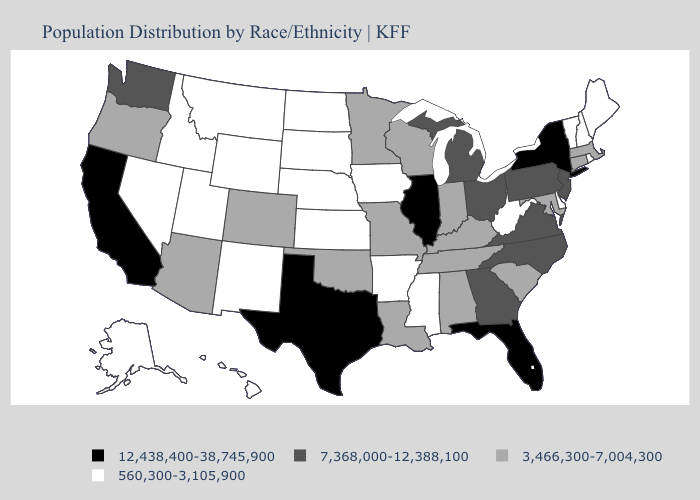Name the states that have a value in the range 7,368,000-12,388,100?
Concise answer only. Georgia, Michigan, New Jersey, North Carolina, Ohio, Pennsylvania, Virginia, Washington. Name the states that have a value in the range 7,368,000-12,388,100?
Quick response, please. Georgia, Michigan, New Jersey, North Carolina, Ohio, Pennsylvania, Virginia, Washington. Which states have the highest value in the USA?
Concise answer only. California, Florida, Illinois, New York, Texas. What is the lowest value in the USA?
Be succinct. 560,300-3,105,900. What is the value of Arkansas?
Keep it brief. 560,300-3,105,900. Name the states that have a value in the range 12,438,400-38,745,900?
Concise answer only. California, Florida, Illinois, New York, Texas. Name the states that have a value in the range 12,438,400-38,745,900?
Concise answer only. California, Florida, Illinois, New York, Texas. Does North Dakota have the lowest value in the USA?
Write a very short answer. Yes. What is the value of Nevada?
Answer briefly. 560,300-3,105,900. What is the value of Oregon?
Short answer required. 3,466,300-7,004,300. What is the value of South Dakota?
Be succinct. 560,300-3,105,900. Does Indiana have the highest value in the USA?
Answer briefly. No. Does Pennsylvania have the lowest value in the USA?
Quick response, please. No. Does Wyoming have the lowest value in the USA?
Concise answer only. Yes. What is the lowest value in states that border Idaho?
Answer briefly. 560,300-3,105,900. 